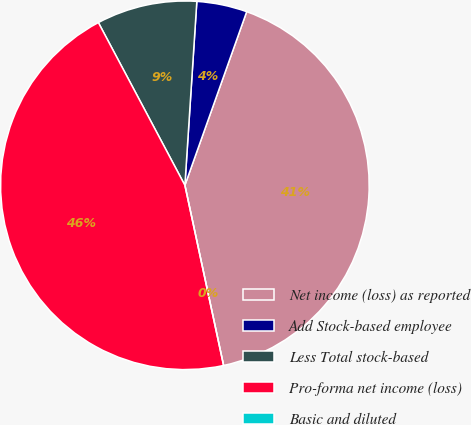<chart> <loc_0><loc_0><loc_500><loc_500><pie_chart><fcel>Net income (loss) as reported<fcel>Add Stock-based employee<fcel>Less Total stock-based<fcel>Pro-forma net income (loss)<fcel>Basic and diluted<nl><fcel>41.19%<fcel>4.41%<fcel>8.81%<fcel>45.59%<fcel>0.0%<nl></chart> 